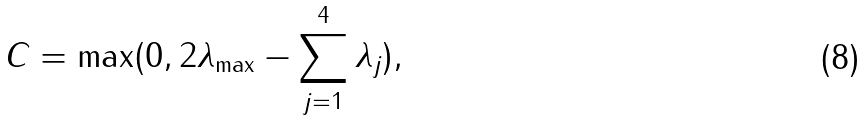<formula> <loc_0><loc_0><loc_500><loc_500>C = \max ( 0 , 2 { \lambda } _ { \max } - \sum _ { j = 1 } ^ { 4 } { \lambda } _ { j } ) ,</formula> 